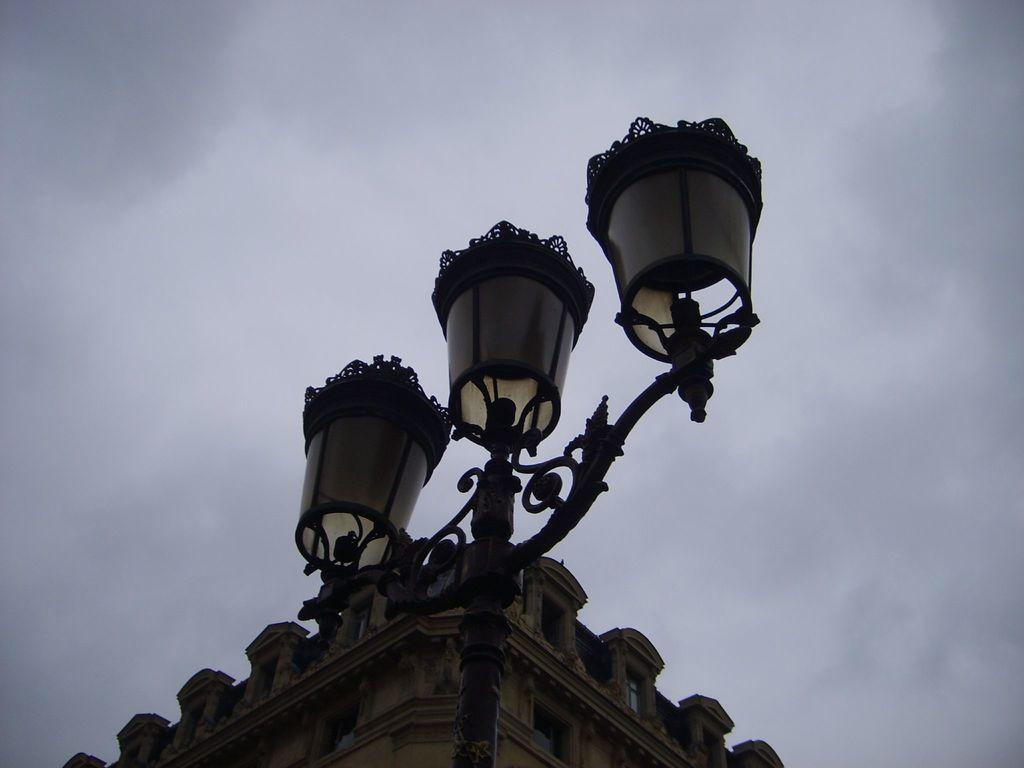What type of structure is visible in the image? There is an upper part of a building in the image. What lighting feature is present in the image? There is a pole with three lamps in the image. How close is the pole with lamps to the building? The pole with lamps is near the building. What can be seen in the background of the image? There is a sky visible in the background of the image. What atmospheric elements are present in the sky? Clouds are present in the sky. What type of plate is used to taste the brake in the image? There is no plate or brake present in the image. The image features an upper part of a building and a pole with three lamps, along with a sky in the background. 